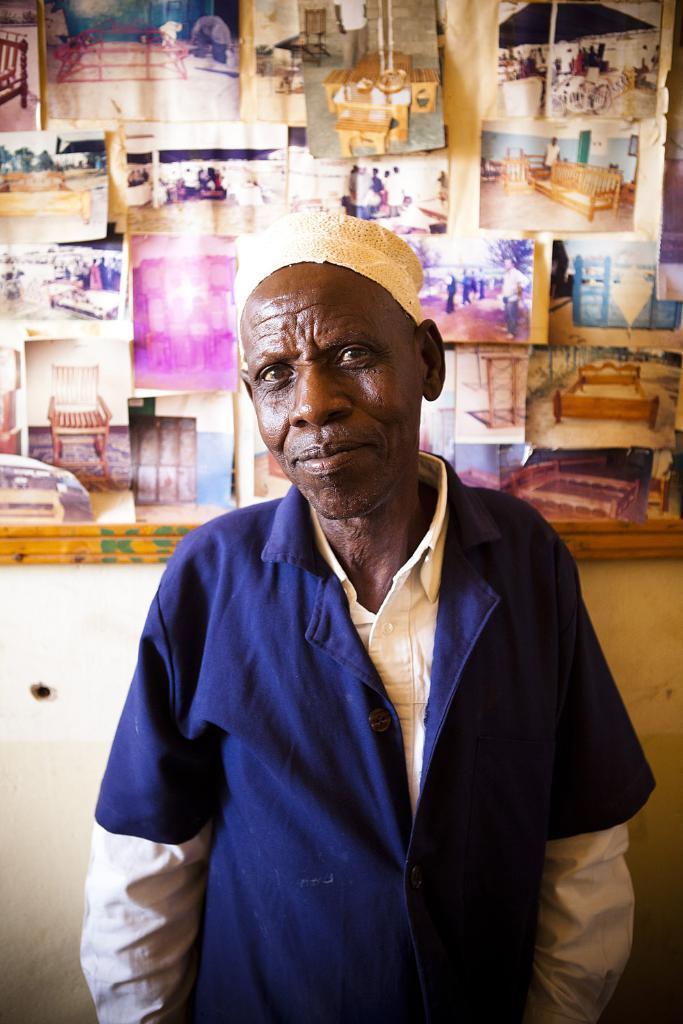How would you summarize this image in a sentence or two? In the middle of the image there is a man standing on the floor. In the background there is a wall and there is a board with many pictures and posters on it. The board is placed on the wall. 